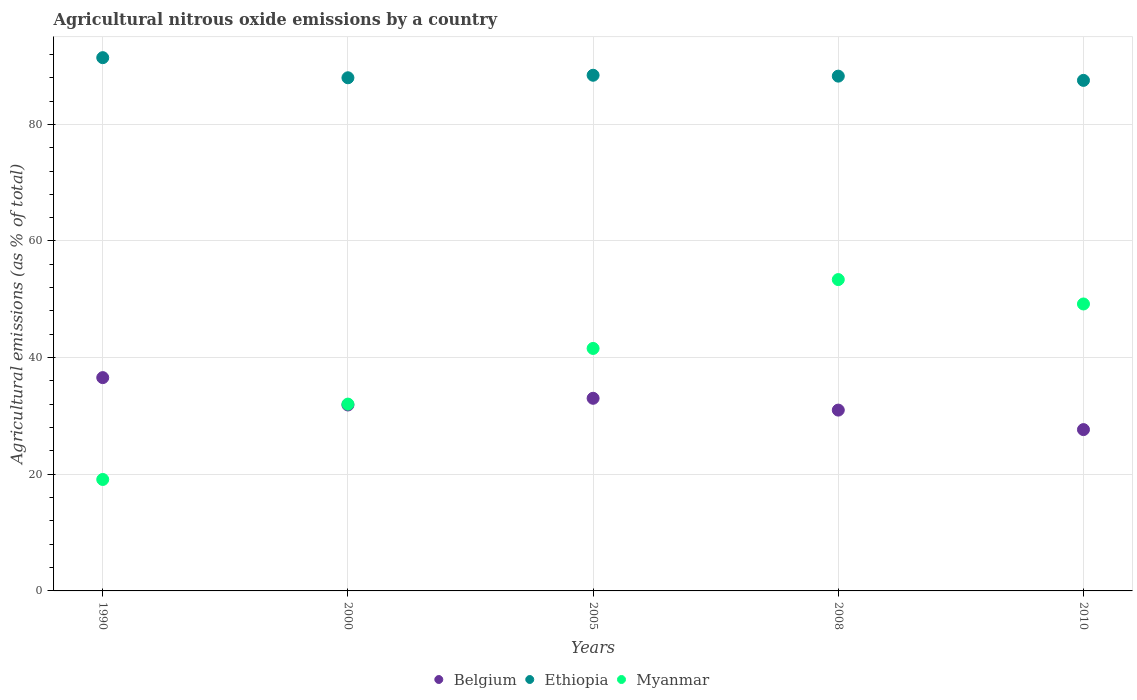Is the number of dotlines equal to the number of legend labels?
Give a very brief answer. Yes. What is the amount of agricultural nitrous oxide emitted in Myanmar in 2005?
Keep it short and to the point. 41.58. Across all years, what is the maximum amount of agricultural nitrous oxide emitted in Myanmar?
Your answer should be compact. 53.38. Across all years, what is the minimum amount of agricultural nitrous oxide emitted in Myanmar?
Your response must be concise. 19.11. What is the total amount of agricultural nitrous oxide emitted in Myanmar in the graph?
Your answer should be very brief. 195.3. What is the difference between the amount of agricultural nitrous oxide emitted in Ethiopia in 2000 and that in 2010?
Offer a very short reply. 0.45. What is the difference between the amount of agricultural nitrous oxide emitted in Myanmar in 2000 and the amount of agricultural nitrous oxide emitted in Belgium in 2010?
Provide a succinct answer. 4.37. What is the average amount of agricultural nitrous oxide emitted in Ethiopia per year?
Your answer should be compact. 88.73. In the year 2010, what is the difference between the amount of agricultural nitrous oxide emitted in Belgium and amount of agricultural nitrous oxide emitted in Myanmar?
Your answer should be compact. -21.54. What is the ratio of the amount of agricultural nitrous oxide emitted in Belgium in 2000 to that in 2010?
Provide a short and direct response. 1.15. What is the difference between the highest and the second highest amount of agricultural nitrous oxide emitted in Belgium?
Provide a short and direct response. 3.54. What is the difference between the highest and the lowest amount of agricultural nitrous oxide emitted in Myanmar?
Your answer should be compact. 34.27. Is the amount of agricultural nitrous oxide emitted in Belgium strictly greater than the amount of agricultural nitrous oxide emitted in Myanmar over the years?
Offer a very short reply. No. What is the difference between two consecutive major ticks on the Y-axis?
Ensure brevity in your answer.  20. Are the values on the major ticks of Y-axis written in scientific E-notation?
Give a very brief answer. No. Does the graph contain grids?
Offer a terse response. Yes. Where does the legend appear in the graph?
Keep it short and to the point. Bottom center. How are the legend labels stacked?
Ensure brevity in your answer.  Horizontal. What is the title of the graph?
Offer a very short reply. Agricultural nitrous oxide emissions by a country. What is the label or title of the Y-axis?
Your answer should be very brief. Agricultural emissions (as % of total). What is the Agricultural emissions (as % of total) of Belgium in 1990?
Ensure brevity in your answer.  36.57. What is the Agricultural emissions (as % of total) of Ethiopia in 1990?
Give a very brief answer. 91.43. What is the Agricultural emissions (as % of total) in Myanmar in 1990?
Ensure brevity in your answer.  19.11. What is the Agricultural emissions (as % of total) of Belgium in 2000?
Provide a succinct answer. 31.88. What is the Agricultural emissions (as % of total) of Ethiopia in 2000?
Your response must be concise. 87.99. What is the Agricultural emissions (as % of total) in Myanmar in 2000?
Keep it short and to the point. 32.03. What is the Agricultural emissions (as % of total) in Belgium in 2005?
Your response must be concise. 33.03. What is the Agricultural emissions (as % of total) of Ethiopia in 2005?
Offer a terse response. 88.42. What is the Agricultural emissions (as % of total) in Myanmar in 2005?
Provide a succinct answer. 41.58. What is the Agricultural emissions (as % of total) of Belgium in 2008?
Ensure brevity in your answer.  31. What is the Agricultural emissions (as % of total) of Ethiopia in 2008?
Give a very brief answer. 88.27. What is the Agricultural emissions (as % of total) in Myanmar in 2008?
Offer a terse response. 53.38. What is the Agricultural emissions (as % of total) of Belgium in 2010?
Provide a succinct answer. 27.66. What is the Agricultural emissions (as % of total) in Ethiopia in 2010?
Your answer should be compact. 87.54. What is the Agricultural emissions (as % of total) in Myanmar in 2010?
Your answer should be very brief. 49.2. Across all years, what is the maximum Agricultural emissions (as % of total) of Belgium?
Give a very brief answer. 36.57. Across all years, what is the maximum Agricultural emissions (as % of total) in Ethiopia?
Ensure brevity in your answer.  91.43. Across all years, what is the maximum Agricultural emissions (as % of total) of Myanmar?
Make the answer very short. 53.38. Across all years, what is the minimum Agricultural emissions (as % of total) of Belgium?
Your answer should be very brief. 27.66. Across all years, what is the minimum Agricultural emissions (as % of total) of Ethiopia?
Make the answer very short. 87.54. Across all years, what is the minimum Agricultural emissions (as % of total) in Myanmar?
Your answer should be very brief. 19.11. What is the total Agricultural emissions (as % of total) in Belgium in the graph?
Your answer should be very brief. 160.15. What is the total Agricultural emissions (as % of total) in Ethiopia in the graph?
Provide a succinct answer. 443.64. What is the total Agricultural emissions (as % of total) in Myanmar in the graph?
Your response must be concise. 195.3. What is the difference between the Agricultural emissions (as % of total) in Belgium in 1990 and that in 2000?
Your answer should be very brief. 4.69. What is the difference between the Agricultural emissions (as % of total) in Ethiopia in 1990 and that in 2000?
Offer a terse response. 3.45. What is the difference between the Agricultural emissions (as % of total) of Myanmar in 1990 and that in 2000?
Offer a terse response. -12.92. What is the difference between the Agricultural emissions (as % of total) of Belgium in 1990 and that in 2005?
Give a very brief answer. 3.54. What is the difference between the Agricultural emissions (as % of total) in Ethiopia in 1990 and that in 2005?
Provide a short and direct response. 3.02. What is the difference between the Agricultural emissions (as % of total) in Myanmar in 1990 and that in 2005?
Keep it short and to the point. -22.47. What is the difference between the Agricultural emissions (as % of total) in Belgium in 1990 and that in 2008?
Give a very brief answer. 5.57. What is the difference between the Agricultural emissions (as % of total) in Ethiopia in 1990 and that in 2008?
Offer a very short reply. 3.17. What is the difference between the Agricultural emissions (as % of total) in Myanmar in 1990 and that in 2008?
Offer a terse response. -34.27. What is the difference between the Agricultural emissions (as % of total) in Belgium in 1990 and that in 2010?
Keep it short and to the point. 8.91. What is the difference between the Agricultural emissions (as % of total) in Ethiopia in 1990 and that in 2010?
Provide a succinct answer. 3.89. What is the difference between the Agricultural emissions (as % of total) of Myanmar in 1990 and that in 2010?
Offer a very short reply. -30.09. What is the difference between the Agricultural emissions (as % of total) in Belgium in 2000 and that in 2005?
Make the answer very short. -1.15. What is the difference between the Agricultural emissions (as % of total) of Ethiopia in 2000 and that in 2005?
Offer a very short reply. -0.43. What is the difference between the Agricultural emissions (as % of total) in Myanmar in 2000 and that in 2005?
Your response must be concise. -9.54. What is the difference between the Agricultural emissions (as % of total) of Belgium in 2000 and that in 2008?
Offer a terse response. 0.88. What is the difference between the Agricultural emissions (as % of total) of Ethiopia in 2000 and that in 2008?
Keep it short and to the point. -0.28. What is the difference between the Agricultural emissions (as % of total) in Myanmar in 2000 and that in 2008?
Offer a terse response. -21.35. What is the difference between the Agricultural emissions (as % of total) of Belgium in 2000 and that in 2010?
Your answer should be very brief. 4.22. What is the difference between the Agricultural emissions (as % of total) of Ethiopia in 2000 and that in 2010?
Keep it short and to the point. 0.45. What is the difference between the Agricultural emissions (as % of total) in Myanmar in 2000 and that in 2010?
Your answer should be compact. -17.17. What is the difference between the Agricultural emissions (as % of total) in Belgium in 2005 and that in 2008?
Provide a succinct answer. 2.02. What is the difference between the Agricultural emissions (as % of total) in Ethiopia in 2005 and that in 2008?
Provide a succinct answer. 0.15. What is the difference between the Agricultural emissions (as % of total) of Myanmar in 2005 and that in 2008?
Give a very brief answer. -11.81. What is the difference between the Agricultural emissions (as % of total) in Belgium in 2005 and that in 2010?
Your response must be concise. 5.37. What is the difference between the Agricultural emissions (as % of total) of Ethiopia in 2005 and that in 2010?
Provide a succinct answer. 0.88. What is the difference between the Agricultural emissions (as % of total) in Myanmar in 2005 and that in 2010?
Provide a short and direct response. -7.62. What is the difference between the Agricultural emissions (as % of total) in Belgium in 2008 and that in 2010?
Make the answer very short. 3.34. What is the difference between the Agricultural emissions (as % of total) in Ethiopia in 2008 and that in 2010?
Offer a very short reply. 0.73. What is the difference between the Agricultural emissions (as % of total) in Myanmar in 2008 and that in 2010?
Your response must be concise. 4.18. What is the difference between the Agricultural emissions (as % of total) in Belgium in 1990 and the Agricultural emissions (as % of total) in Ethiopia in 2000?
Your answer should be compact. -51.41. What is the difference between the Agricultural emissions (as % of total) in Belgium in 1990 and the Agricultural emissions (as % of total) in Myanmar in 2000?
Ensure brevity in your answer.  4.54. What is the difference between the Agricultural emissions (as % of total) in Ethiopia in 1990 and the Agricultural emissions (as % of total) in Myanmar in 2000?
Your answer should be compact. 59.4. What is the difference between the Agricultural emissions (as % of total) in Belgium in 1990 and the Agricultural emissions (as % of total) in Ethiopia in 2005?
Ensure brevity in your answer.  -51.84. What is the difference between the Agricultural emissions (as % of total) of Belgium in 1990 and the Agricultural emissions (as % of total) of Myanmar in 2005?
Your answer should be compact. -5. What is the difference between the Agricultural emissions (as % of total) in Ethiopia in 1990 and the Agricultural emissions (as % of total) in Myanmar in 2005?
Make the answer very short. 49.86. What is the difference between the Agricultural emissions (as % of total) in Belgium in 1990 and the Agricultural emissions (as % of total) in Ethiopia in 2008?
Your answer should be very brief. -51.69. What is the difference between the Agricultural emissions (as % of total) of Belgium in 1990 and the Agricultural emissions (as % of total) of Myanmar in 2008?
Give a very brief answer. -16.81. What is the difference between the Agricultural emissions (as % of total) of Ethiopia in 1990 and the Agricultural emissions (as % of total) of Myanmar in 2008?
Offer a very short reply. 38.05. What is the difference between the Agricultural emissions (as % of total) in Belgium in 1990 and the Agricultural emissions (as % of total) in Ethiopia in 2010?
Give a very brief answer. -50.97. What is the difference between the Agricultural emissions (as % of total) in Belgium in 1990 and the Agricultural emissions (as % of total) in Myanmar in 2010?
Provide a succinct answer. -12.63. What is the difference between the Agricultural emissions (as % of total) of Ethiopia in 1990 and the Agricultural emissions (as % of total) of Myanmar in 2010?
Your response must be concise. 42.23. What is the difference between the Agricultural emissions (as % of total) of Belgium in 2000 and the Agricultural emissions (as % of total) of Ethiopia in 2005?
Provide a short and direct response. -56.54. What is the difference between the Agricultural emissions (as % of total) of Belgium in 2000 and the Agricultural emissions (as % of total) of Myanmar in 2005?
Offer a terse response. -9.7. What is the difference between the Agricultural emissions (as % of total) in Ethiopia in 2000 and the Agricultural emissions (as % of total) in Myanmar in 2005?
Your answer should be very brief. 46.41. What is the difference between the Agricultural emissions (as % of total) of Belgium in 2000 and the Agricultural emissions (as % of total) of Ethiopia in 2008?
Offer a very short reply. -56.39. What is the difference between the Agricultural emissions (as % of total) in Belgium in 2000 and the Agricultural emissions (as % of total) in Myanmar in 2008?
Give a very brief answer. -21.5. What is the difference between the Agricultural emissions (as % of total) in Ethiopia in 2000 and the Agricultural emissions (as % of total) in Myanmar in 2008?
Offer a very short reply. 34.6. What is the difference between the Agricultural emissions (as % of total) of Belgium in 2000 and the Agricultural emissions (as % of total) of Ethiopia in 2010?
Offer a very short reply. -55.66. What is the difference between the Agricultural emissions (as % of total) in Belgium in 2000 and the Agricultural emissions (as % of total) in Myanmar in 2010?
Provide a short and direct response. -17.32. What is the difference between the Agricultural emissions (as % of total) of Ethiopia in 2000 and the Agricultural emissions (as % of total) of Myanmar in 2010?
Make the answer very short. 38.79. What is the difference between the Agricultural emissions (as % of total) in Belgium in 2005 and the Agricultural emissions (as % of total) in Ethiopia in 2008?
Your response must be concise. -55.24. What is the difference between the Agricultural emissions (as % of total) of Belgium in 2005 and the Agricultural emissions (as % of total) of Myanmar in 2008?
Ensure brevity in your answer.  -20.35. What is the difference between the Agricultural emissions (as % of total) in Ethiopia in 2005 and the Agricultural emissions (as % of total) in Myanmar in 2008?
Provide a succinct answer. 35.04. What is the difference between the Agricultural emissions (as % of total) in Belgium in 2005 and the Agricultural emissions (as % of total) in Ethiopia in 2010?
Ensure brevity in your answer.  -54.51. What is the difference between the Agricultural emissions (as % of total) of Belgium in 2005 and the Agricultural emissions (as % of total) of Myanmar in 2010?
Your answer should be very brief. -16.17. What is the difference between the Agricultural emissions (as % of total) in Ethiopia in 2005 and the Agricultural emissions (as % of total) in Myanmar in 2010?
Make the answer very short. 39.22. What is the difference between the Agricultural emissions (as % of total) of Belgium in 2008 and the Agricultural emissions (as % of total) of Ethiopia in 2010?
Your answer should be compact. -56.53. What is the difference between the Agricultural emissions (as % of total) of Belgium in 2008 and the Agricultural emissions (as % of total) of Myanmar in 2010?
Give a very brief answer. -18.2. What is the difference between the Agricultural emissions (as % of total) in Ethiopia in 2008 and the Agricultural emissions (as % of total) in Myanmar in 2010?
Provide a short and direct response. 39.07. What is the average Agricultural emissions (as % of total) of Belgium per year?
Your response must be concise. 32.03. What is the average Agricultural emissions (as % of total) in Ethiopia per year?
Offer a very short reply. 88.73. What is the average Agricultural emissions (as % of total) in Myanmar per year?
Provide a short and direct response. 39.06. In the year 1990, what is the difference between the Agricultural emissions (as % of total) of Belgium and Agricultural emissions (as % of total) of Ethiopia?
Offer a very short reply. -54.86. In the year 1990, what is the difference between the Agricultural emissions (as % of total) in Belgium and Agricultural emissions (as % of total) in Myanmar?
Your answer should be compact. 17.46. In the year 1990, what is the difference between the Agricultural emissions (as % of total) in Ethiopia and Agricultural emissions (as % of total) in Myanmar?
Give a very brief answer. 72.32. In the year 2000, what is the difference between the Agricultural emissions (as % of total) in Belgium and Agricultural emissions (as % of total) in Ethiopia?
Keep it short and to the point. -56.11. In the year 2000, what is the difference between the Agricultural emissions (as % of total) in Belgium and Agricultural emissions (as % of total) in Myanmar?
Your answer should be very brief. -0.15. In the year 2000, what is the difference between the Agricultural emissions (as % of total) in Ethiopia and Agricultural emissions (as % of total) in Myanmar?
Offer a very short reply. 55.95. In the year 2005, what is the difference between the Agricultural emissions (as % of total) in Belgium and Agricultural emissions (as % of total) in Ethiopia?
Offer a terse response. -55.39. In the year 2005, what is the difference between the Agricultural emissions (as % of total) in Belgium and Agricultural emissions (as % of total) in Myanmar?
Your answer should be very brief. -8.55. In the year 2005, what is the difference between the Agricultural emissions (as % of total) of Ethiopia and Agricultural emissions (as % of total) of Myanmar?
Offer a terse response. 46.84. In the year 2008, what is the difference between the Agricultural emissions (as % of total) in Belgium and Agricultural emissions (as % of total) in Ethiopia?
Keep it short and to the point. -57.26. In the year 2008, what is the difference between the Agricultural emissions (as % of total) in Belgium and Agricultural emissions (as % of total) in Myanmar?
Offer a terse response. -22.38. In the year 2008, what is the difference between the Agricultural emissions (as % of total) of Ethiopia and Agricultural emissions (as % of total) of Myanmar?
Make the answer very short. 34.88. In the year 2010, what is the difference between the Agricultural emissions (as % of total) of Belgium and Agricultural emissions (as % of total) of Ethiopia?
Your response must be concise. -59.88. In the year 2010, what is the difference between the Agricultural emissions (as % of total) in Belgium and Agricultural emissions (as % of total) in Myanmar?
Keep it short and to the point. -21.54. In the year 2010, what is the difference between the Agricultural emissions (as % of total) in Ethiopia and Agricultural emissions (as % of total) in Myanmar?
Keep it short and to the point. 38.34. What is the ratio of the Agricultural emissions (as % of total) of Belgium in 1990 to that in 2000?
Provide a short and direct response. 1.15. What is the ratio of the Agricultural emissions (as % of total) in Ethiopia in 1990 to that in 2000?
Offer a terse response. 1.04. What is the ratio of the Agricultural emissions (as % of total) of Myanmar in 1990 to that in 2000?
Give a very brief answer. 0.6. What is the ratio of the Agricultural emissions (as % of total) of Belgium in 1990 to that in 2005?
Provide a short and direct response. 1.11. What is the ratio of the Agricultural emissions (as % of total) in Ethiopia in 1990 to that in 2005?
Your answer should be compact. 1.03. What is the ratio of the Agricultural emissions (as % of total) in Myanmar in 1990 to that in 2005?
Provide a succinct answer. 0.46. What is the ratio of the Agricultural emissions (as % of total) of Belgium in 1990 to that in 2008?
Provide a succinct answer. 1.18. What is the ratio of the Agricultural emissions (as % of total) of Ethiopia in 1990 to that in 2008?
Your response must be concise. 1.04. What is the ratio of the Agricultural emissions (as % of total) of Myanmar in 1990 to that in 2008?
Ensure brevity in your answer.  0.36. What is the ratio of the Agricultural emissions (as % of total) in Belgium in 1990 to that in 2010?
Your answer should be very brief. 1.32. What is the ratio of the Agricultural emissions (as % of total) of Ethiopia in 1990 to that in 2010?
Make the answer very short. 1.04. What is the ratio of the Agricultural emissions (as % of total) in Myanmar in 1990 to that in 2010?
Provide a succinct answer. 0.39. What is the ratio of the Agricultural emissions (as % of total) of Belgium in 2000 to that in 2005?
Offer a very short reply. 0.97. What is the ratio of the Agricultural emissions (as % of total) of Myanmar in 2000 to that in 2005?
Offer a very short reply. 0.77. What is the ratio of the Agricultural emissions (as % of total) in Belgium in 2000 to that in 2008?
Give a very brief answer. 1.03. What is the ratio of the Agricultural emissions (as % of total) of Ethiopia in 2000 to that in 2008?
Offer a terse response. 1. What is the ratio of the Agricultural emissions (as % of total) of Myanmar in 2000 to that in 2008?
Ensure brevity in your answer.  0.6. What is the ratio of the Agricultural emissions (as % of total) of Belgium in 2000 to that in 2010?
Make the answer very short. 1.15. What is the ratio of the Agricultural emissions (as % of total) in Ethiopia in 2000 to that in 2010?
Your answer should be compact. 1.01. What is the ratio of the Agricultural emissions (as % of total) of Myanmar in 2000 to that in 2010?
Keep it short and to the point. 0.65. What is the ratio of the Agricultural emissions (as % of total) of Belgium in 2005 to that in 2008?
Your answer should be very brief. 1.07. What is the ratio of the Agricultural emissions (as % of total) of Myanmar in 2005 to that in 2008?
Offer a terse response. 0.78. What is the ratio of the Agricultural emissions (as % of total) of Belgium in 2005 to that in 2010?
Your answer should be compact. 1.19. What is the ratio of the Agricultural emissions (as % of total) in Ethiopia in 2005 to that in 2010?
Ensure brevity in your answer.  1.01. What is the ratio of the Agricultural emissions (as % of total) of Myanmar in 2005 to that in 2010?
Your answer should be very brief. 0.85. What is the ratio of the Agricultural emissions (as % of total) of Belgium in 2008 to that in 2010?
Your answer should be very brief. 1.12. What is the ratio of the Agricultural emissions (as % of total) of Ethiopia in 2008 to that in 2010?
Make the answer very short. 1.01. What is the ratio of the Agricultural emissions (as % of total) of Myanmar in 2008 to that in 2010?
Keep it short and to the point. 1.08. What is the difference between the highest and the second highest Agricultural emissions (as % of total) of Belgium?
Keep it short and to the point. 3.54. What is the difference between the highest and the second highest Agricultural emissions (as % of total) in Ethiopia?
Offer a terse response. 3.02. What is the difference between the highest and the second highest Agricultural emissions (as % of total) of Myanmar?
Offer a very short reply. 4.18. What is the difference between the highest and the lowest Agricultural emissions (as % of total) of Belgium?
Provide a short and direct response. 8.91. What is the difference between the highest and the lowest Agricultural emissions (as % of total) of Ethiopia?
Provide a short and direct response. 3.89. What is the difference between the highest and the lowest Agricultural emissions (as % of total) in Myanmar?
Provide a succinct answer. 34.27. 